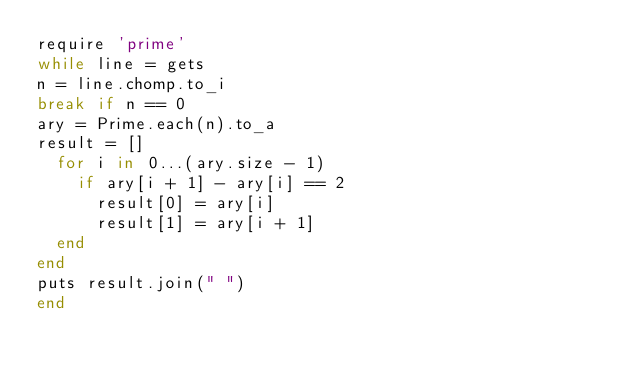Convert code to text. <code><loc_0><loc_0><loc_500><loc_500><_Ruby_>require 'prime'
while line = gets
n = line.chomp.to_i
break if n == 0
ary = Prime.each(n).to_a
result = []
  for i in 0...(ary.size - 1)
    if ary[i + 1] - ary[i] == 2
      result[0] = ary[i]
      result[1] = ary[i + 1]
  end
end
puts result.join(" ")
end
</code> 